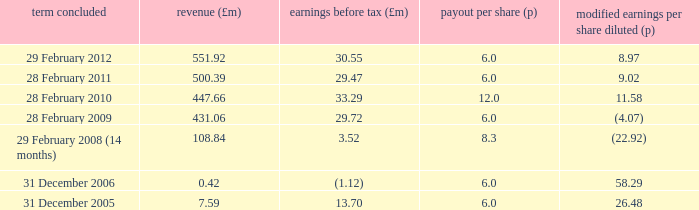What was the profit before tax when the turnover was 431.06? 29.72. 